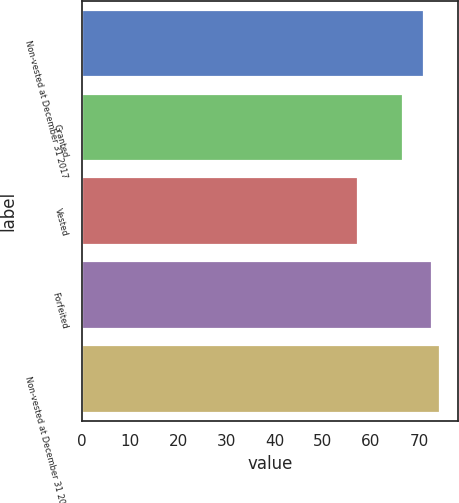Convert chart to OTSL. <chart><loc_0><loc_0><loc_500><loc_500><bar_chart><fcel>Non-vested at December 31 2017<fcel>Granted<fcel>Vested<fcel>Forfeited<fcel>Non-vested at December 31 2018<nl><fcel>71.06<fcel>66.79<fcel>57.37<fcel>72.77<fcel>74.48<nl></chart> 